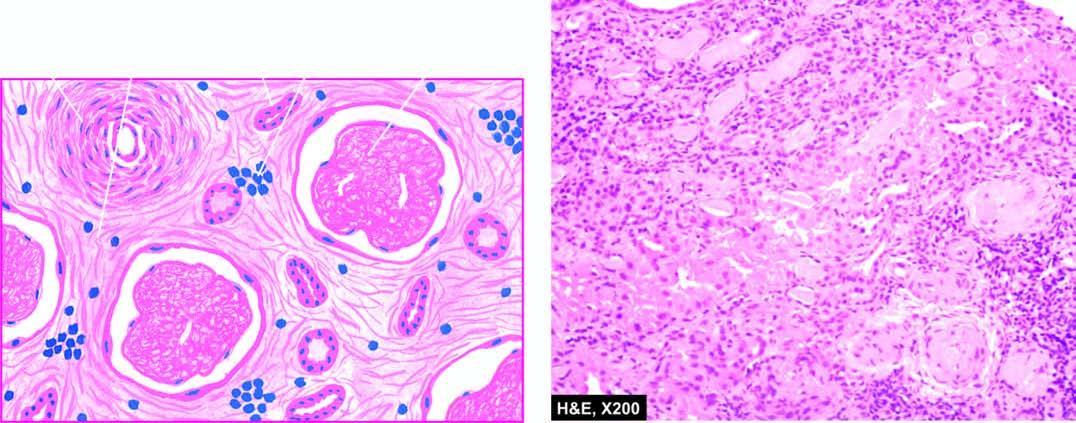how are blood vessels in the interstitium?
Answer the question using a single word or phrase. Hyalinised and thickened 